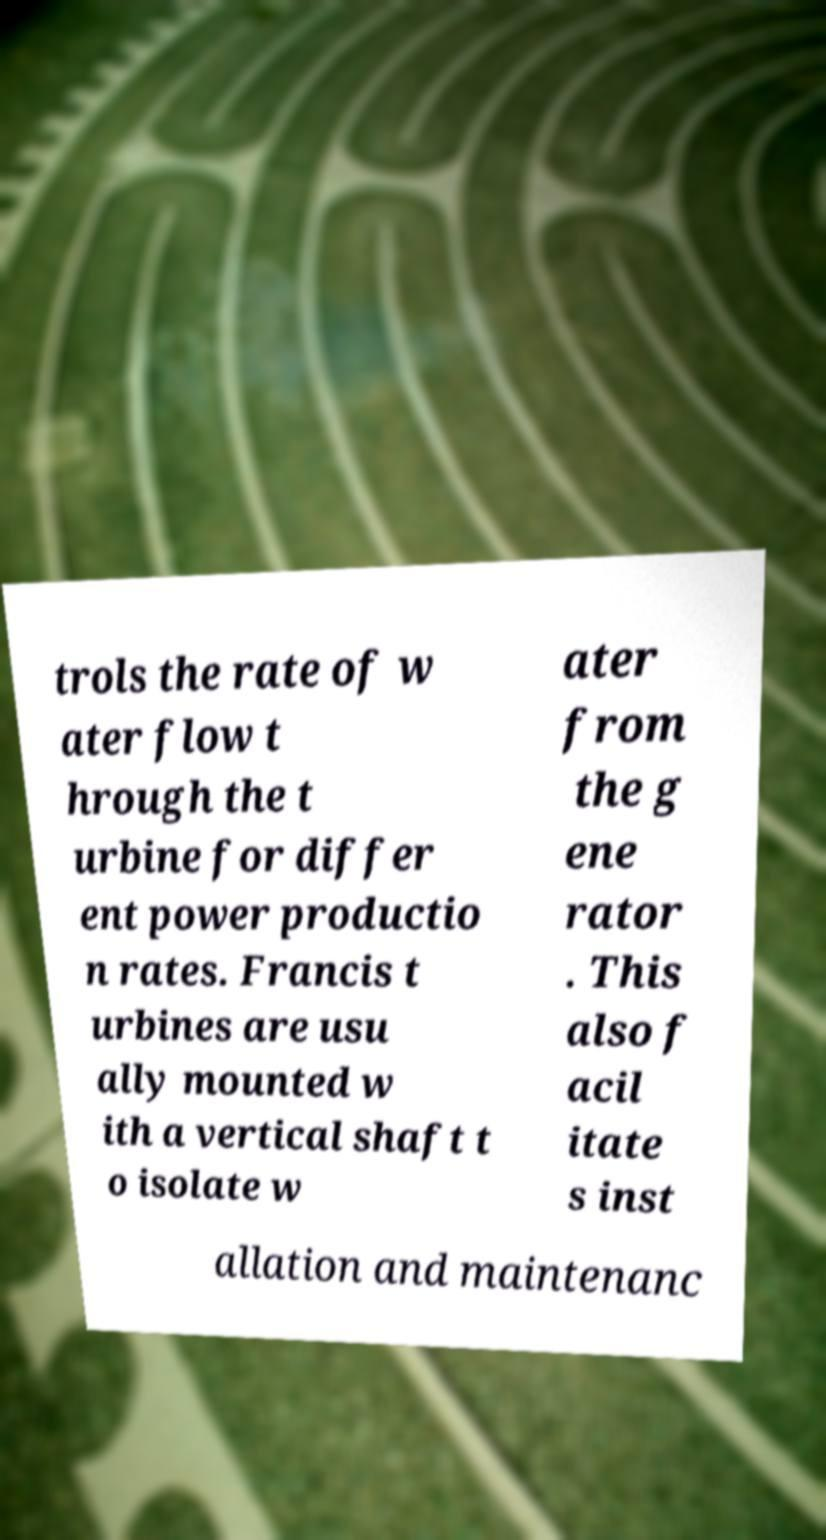What messages or text are displayed in this image? I need them in a readable, typed format. trols the rate of w ater flow t hrough the t urbine for differ ent power productio n rates. Francis t urbines are usu ally mounted w ith a vertical shaft t o isolate w ater from the g ene rator . This also f acil itate s inst allation and maintenanc 